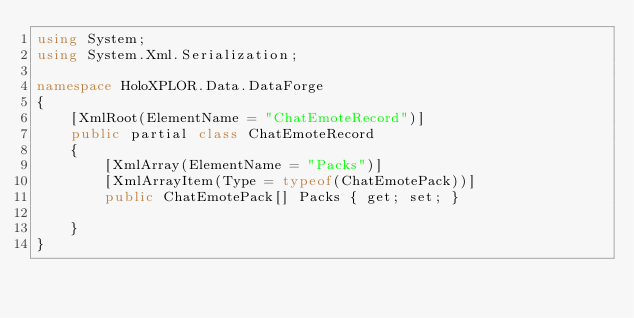<code> <loc_0><loc_0><loc_500><loc_500><_C#_>using System;
using System.Xml.Serialization;

namespace HoloXPLOR.Data.DataForge
{
    [XmlRoot(ElementName = "ChatEmoteRecord")]
    public partial class ChatEmoteRecord
    {
        [XmlArray(ElementName = "Packs")]
        [XmlArrayItem(Type = typeof(ChatEmotePack))]
        public ChatEmotePack[] Packs { get; set; }

    }
}
</code> 